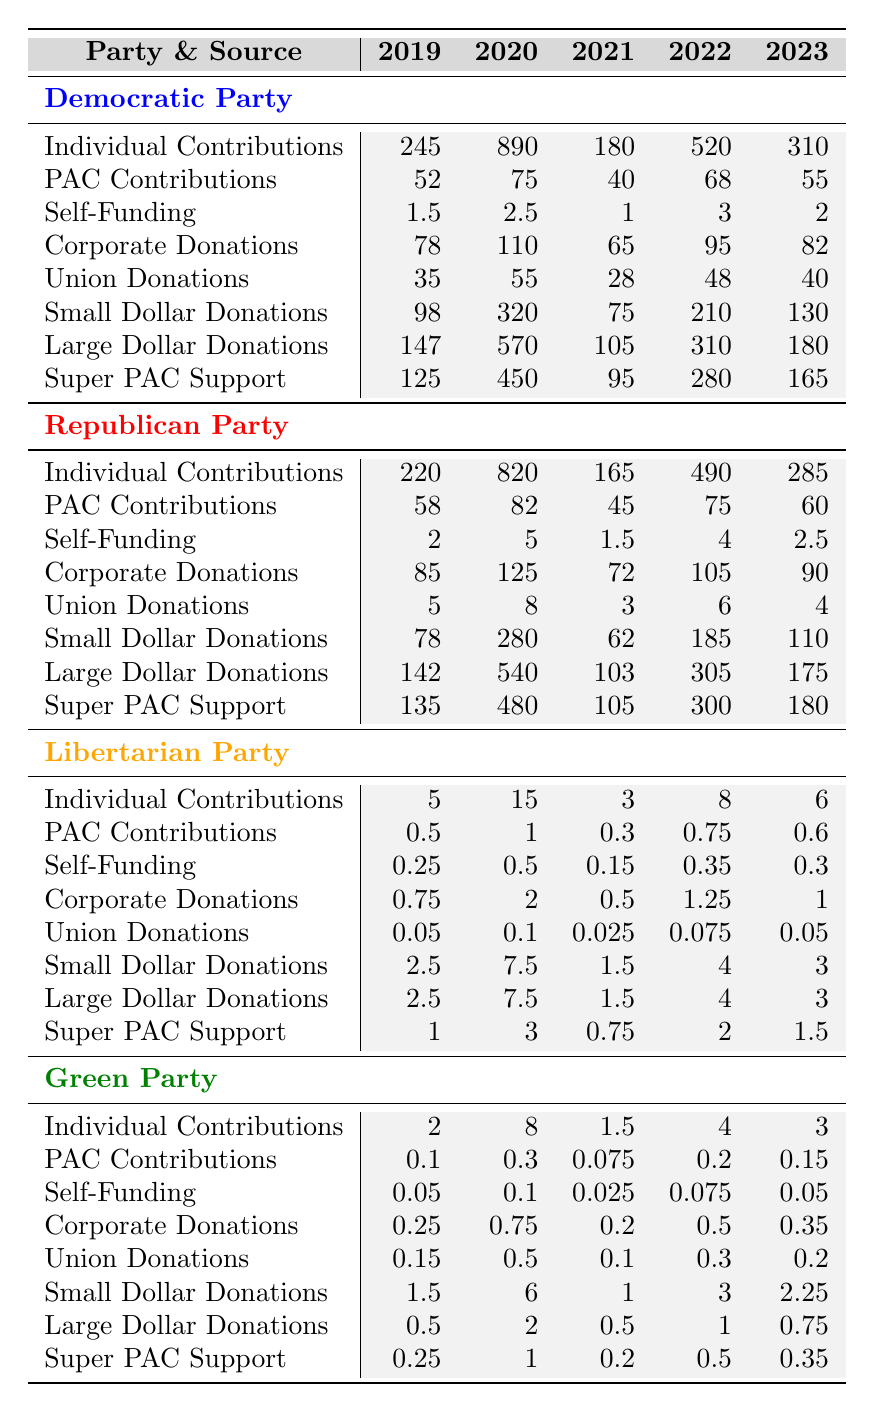What was the largest funding source for the Democratic Party in 2020? In 2020, the Democratic Party received the highest amount from Large Dollar Donations at 570 million.
Answer: Large Dollar Donations Which party had the highest Super PAC Support in 2022? In 2022, the Republican Party had the highest Super PAC Support at 300 million.
Answer: Republican Party What was the total Individual Contributions for the Green Party from 2019 to 2023? The Individual Contributions for the Green Party are 2 million (2019) + 8 million (2020) + 1.5 million (2021) + 4 million (2022) + 3 million (2023) = 18.5 million.
Answer: 18.5 million Did the Libertarian Party receive more in Corporate Donations in 2020 or 2023? In 2020, the Libertarian Party received 2 million in Corporate Donations, while in 2023 they received 1 million. Thus, they received more in 2020.
Answer: Yes What was the average PAC Contributions for the Republican Party over the last five years? The total PAC Contributions for the Republican Party are 58 million (2019) + 82 million (2020) + 45 million (2021) + 75 million (2022) + 60 million (2023) = 320 million. The average is 320 million / 5 = 64 million.
Answer: 64 million Which party had the lowest Small Dollar Donations in 2021? In 2021, the Libertarian Party had the lowest Small Dollar Donations at 1.5 million.
Answer: Libertarian Party What is the difference between the Super PAC Support for the Democratic Party in 2020 and 2023? In 2020, the Democratic Party's Super PAC Support was 450 million, and in 2023 it was 165 million. The difference is 450 million - 165 million = 285 million.
Answer: 285 million Between 2019 and 2023, which party had the most significant increase in Individual Contributions? The Democratic Party had an increase of 890 million (2020) - 245 million (2019) = 645 million, which is more than any other party.
Answer: Democratic Party In which year did the Republican Party see the highest total funding from Corporate Donations? The Republican Party had the highest Corporate Donations in 2020 at 125 million, compared to other years.
Answer: 2020 Was the total funding for the Green Party's Large Dollar Donations in 2022 greater than their total funding for Self-Funding in 2023? The Green Party had 1 million in Large Dollar Donations in 2022 and 0.05 million in Self-Funding in 2023. Since 1 million > 0.05 million, it is greater.
Answer: Yes 